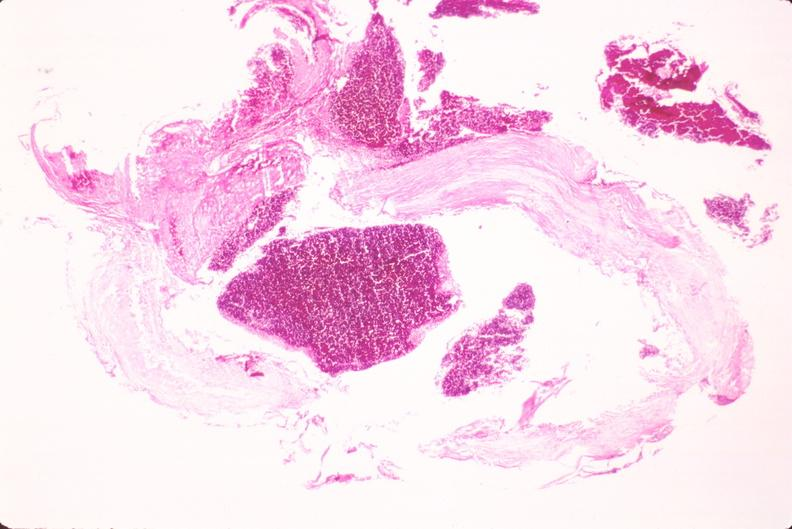what is present?
Answer the question using a single word or phrase. Vasculature 